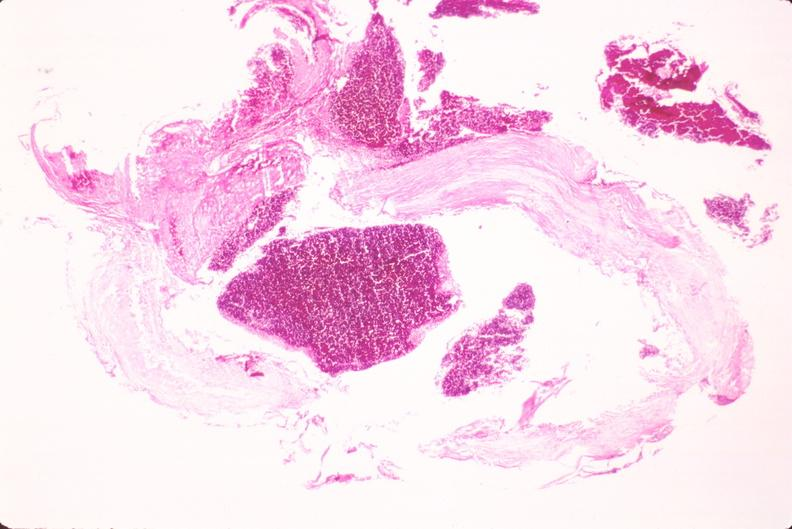what is present?
Answer the question using a single word or phrase. Vasculature 